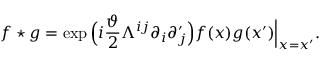<formula> <loc_0><loc_0><loc_500><loc_500>f ^ { * } g = \exp \Big ( i \frac { \vartheta } { 2 } \Lambda ^ { i j } \partial _ { i } \partial _ { j } ^ { \prime } \Big ) f ( x ) g ( x ^ { \prime } ) \Big | _ { x = x ^ { \prime } } .</formula> 